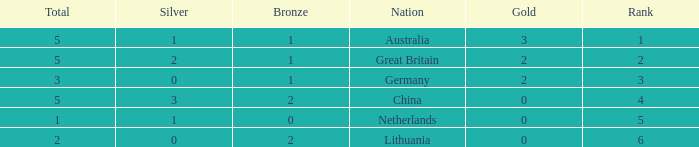Would you mind parsing the complete table? {'header': ['Total', 'Silver', 'Bronze', 'Nation', 'Gold', 'Rank'], 'rows': [['5', '1', '1', 'Australia', '3', '1'], ['5', '2', '1', 'Great Britain', '2', '2'], ['3', '0', '1', 'Germany', '2', '3'], ['5', '3', '2', 'China', '0', '4'], ['1', '1', '0', 'Netherlands', '0', '5'], ['2', '0', '2', 'Lithuania', '0', '6']]} What is the average Rank when there are 2 bronze, the total is 2 and gold is less than 0? None. 